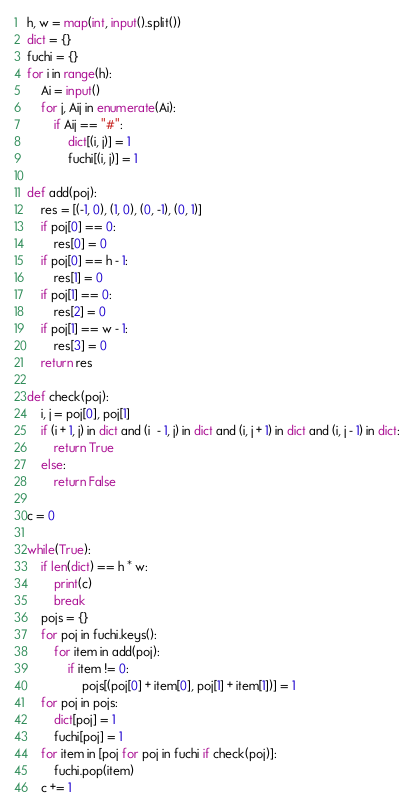<code> <loc_0><loc_0><loc_500><loc_500><_Python_>h, w = map(int, input().split())
dict = {}
fuchi = {}
for i in range(h):
    Ai = input()
    for j, Aij in enumerate(Ai):
        if Aij == "#":
            dict[(i, j)] = 1
            fuchi[(i, j)] = 1

def add(poj):
    res = [(-1, 0), (1, 0), (0, -1), (0, 1)]
    if poj[0] == 0:
        res[0] = 0
    if poj[0] == h - 1:
        res[1] = 0
    if poj[1] == 0:
        res[2] = 0
    if poj[1] == w - 1:
        res[3] = 0
    return res

def check(poj):
    i, j = poj[0], poj[1]
    if (i + 1, j) in dict and (i  - 1, j) in dict and (i, j + 1) in dict and (i, j - 1) in dict:
        return True
    else:
        return False

c = 0

while(True):
    if len(dict) == h * w:
        print(c)
        break
    pojs = {}
    for poj in fuchi.keys():
        for item in add(poj):
            if item != 0:
                pojs[(poj[0] + item[0], poj[1] + item[1])] = 1
    for poj in pojs:
        dict[poj] = 1
        fuchi[poj] = 1
    for item in [poj for poj in fuchi if check(poj)]:
        fuchi.pop(item)
    c += 1
</code> 